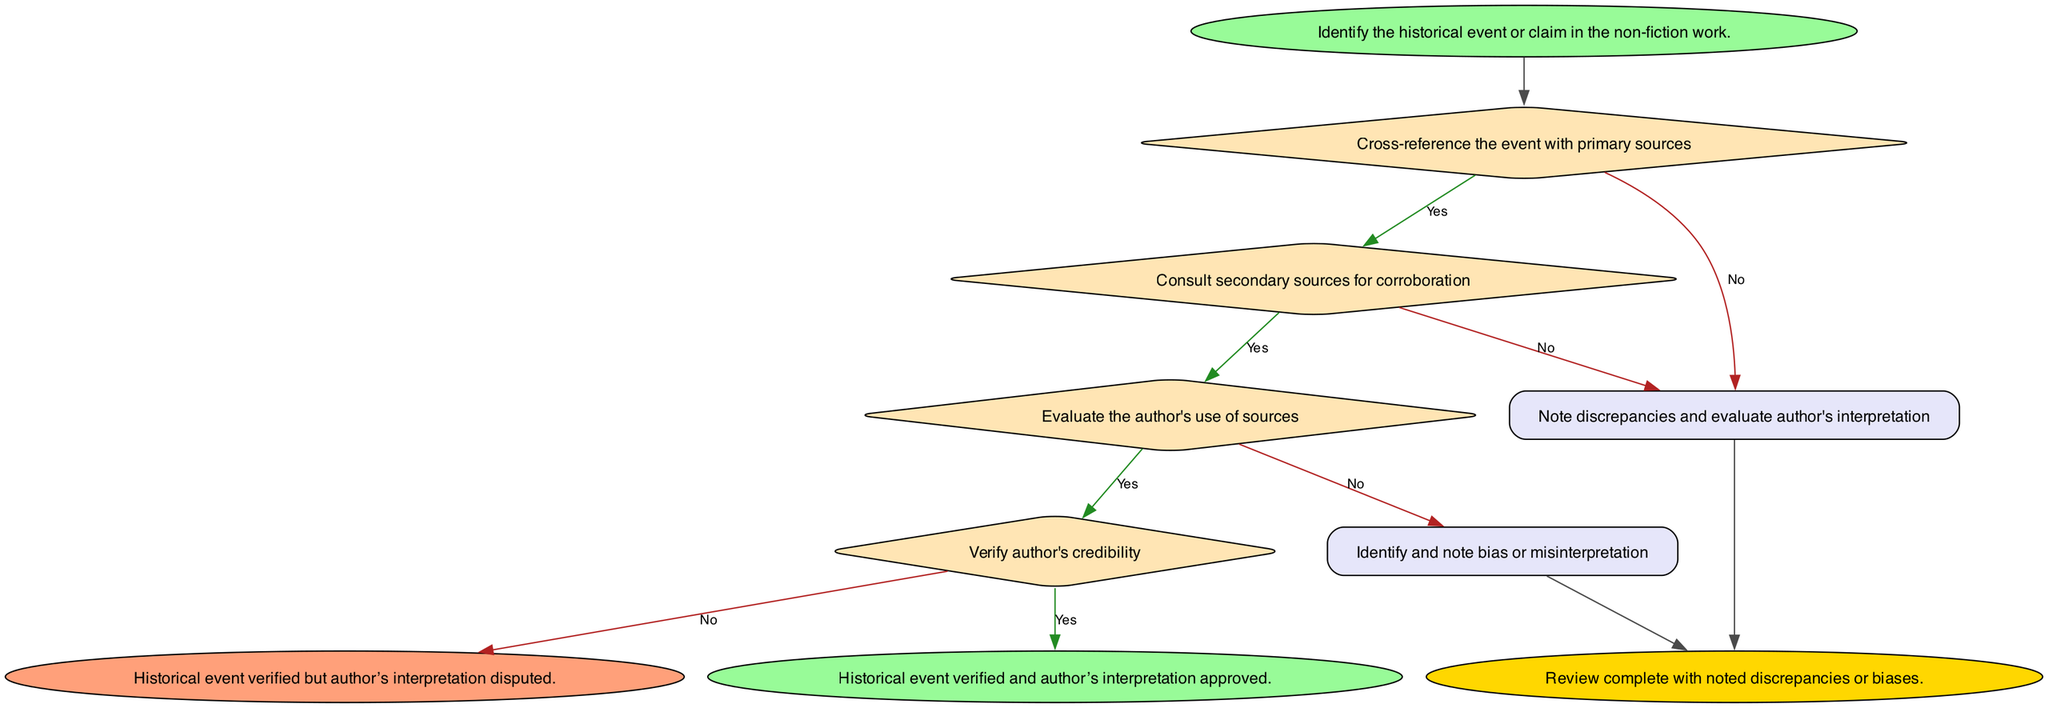What is the starting point of the flowchart? The starting point of the flowchart is defined by the "start" node, which mentions identifying the historical event or claim in the non-fiction work.
Answer: Identify the historical event or claim in the non-fiction work How many decision nodes are there in the diagram? The decision nodes are located at step1, step2, step3, and step4. There are a total of four decision nodes present in the diagram.
Answer: 4 What action occurs if primary sources don't match the event? If the primary sources do not match the event, the flow goes to step2b, which instructs to note discrepancies and evaluate the author's interpretation.
Answer: Note discrepancies and evaluate author's interpretation What happens after corroboration is found from secondary sources? When secondary sources support the event, the flow proceeds to step3, where the author's use of sources is evaluated.
Answer: Evaluate the author's use of sources What does step3b denote in the flowchart? Step3b denotes identifying and noting bias or misinterpretation regarding the author's representation of the historical claim.
Answer: Identify and note bias or misinterpretation What are the outcomes at the end of the process? The outcomes at the end of the process can be either "Historical event verified and author’s interpretation approved," "Historical event verified but author’s interpretation disputed," or "Review complete with noted discrepancies or biases."
Answer: Three outcomes What leads to the approval of the author’s interpretation? The approval of the author's interpretation occurs if the author has a credible background in the topic, as determined in step4.
Answer: Author has a credible background in the topic What is the purpose of "step2b" in the flowchart? "Step2b" serves to document discrepancies and evaluate the author's interpretation after checking the primary sources, indicating a potential issue in the historical claim.
Answer: Note discrepancies and evaluate author's interpretation If the author does not properly cite sources, what is the next step? If the author does not properly cite and interpret sources, the flow moves to step3b, where bias or misinterpretation is identified and noted.
Answer: Identify and note bias or misinterpretation 